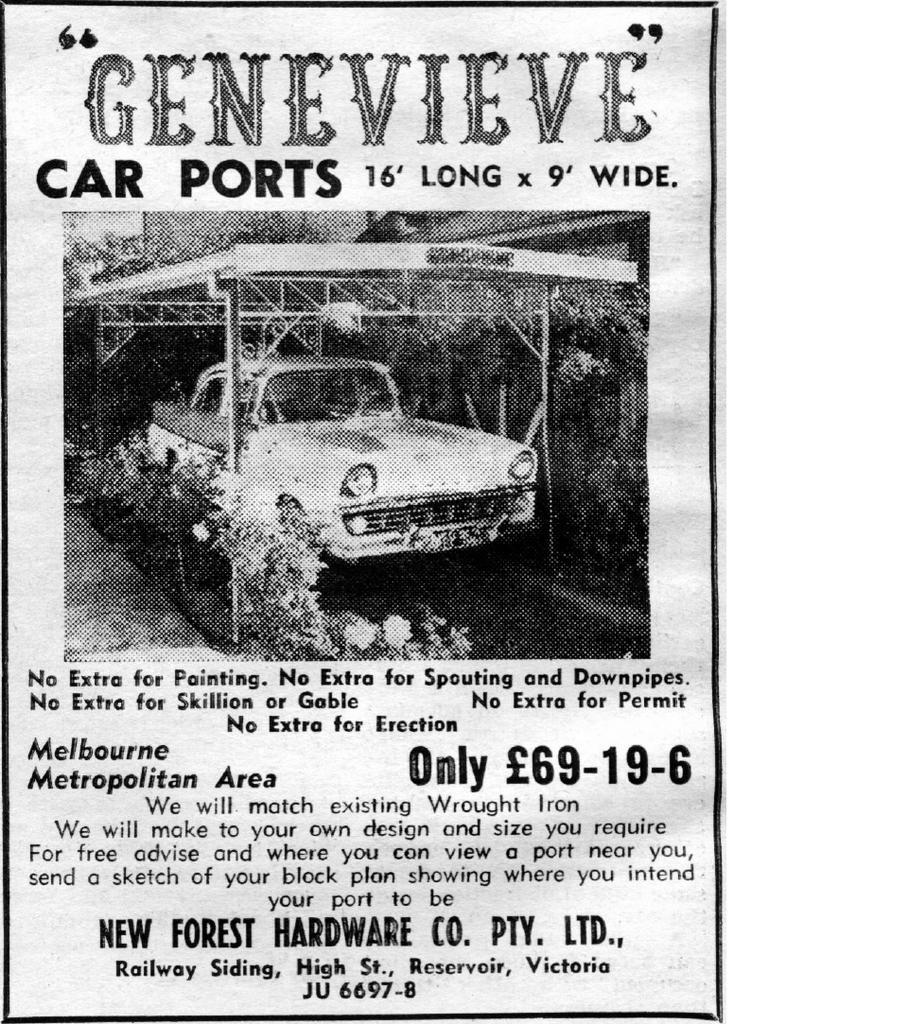Please provide a concise description of this image. This is a poster having one image, black and other colored texts. In the image, there is a vehicle parked on a road, under a shelter. On both sides of this road, there are plants. This poster is having black color border. And the background of this poster is white in color. 